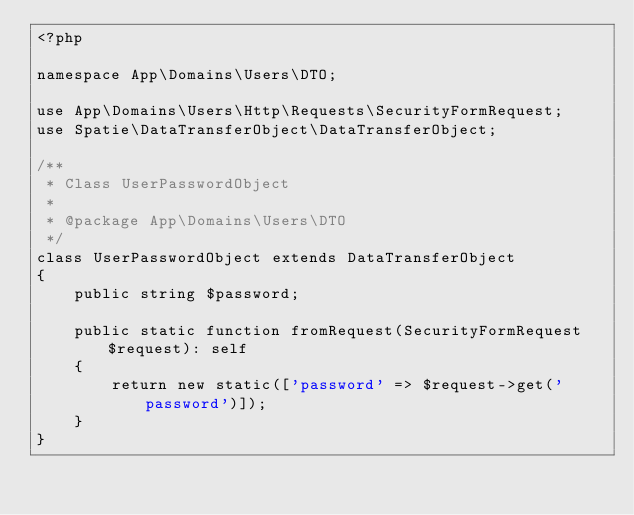Convert code to text. <code><loc_0><loc_0><loc_500><loc_500><_PHP_><?php

namespace App\Domains\Users\DTO;

use App\Domains\Users\Http\Requests\SecurityFormRequest;
use Spatie\DataTransferObject\DataTransferObject;

/**
 * Class UserPasswordObject
 *
 * @package App\Domains\Users\DTO
 */
class UserPasswordObject extends DataTransferObject
{
    public string $password;

    public static function fromRequest(SecurityFormRequest $request): self
    {
        return new static(['password' => $request->get('password')]);
    }
}
</code> 